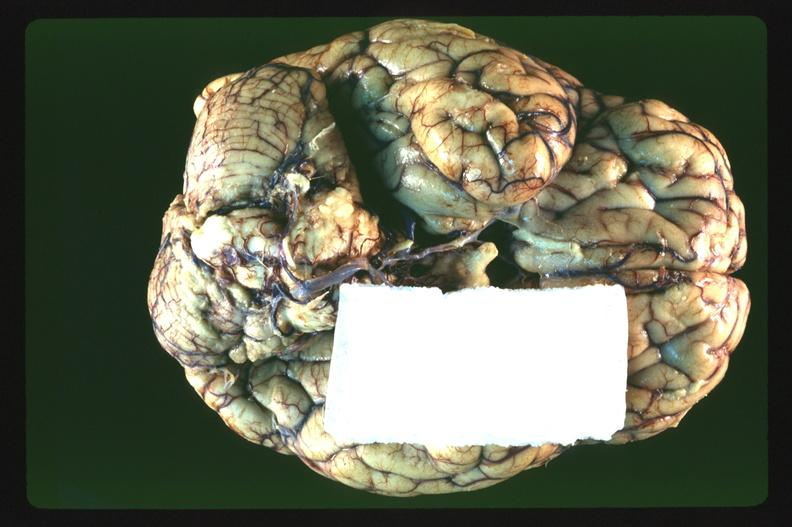what is present?
Answer the question using a single word or phrase. Nervous 